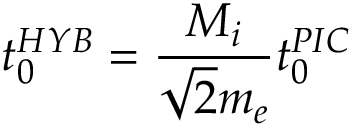<formula> <loc_0><loc_0><loc_500><loc_500>t _ { 0 } ^ { H Y B } = \frac { M _ { i } } { \sqrt { 2 } m _ { e } } t _ { 0 } ^ { P I C }</formula> 